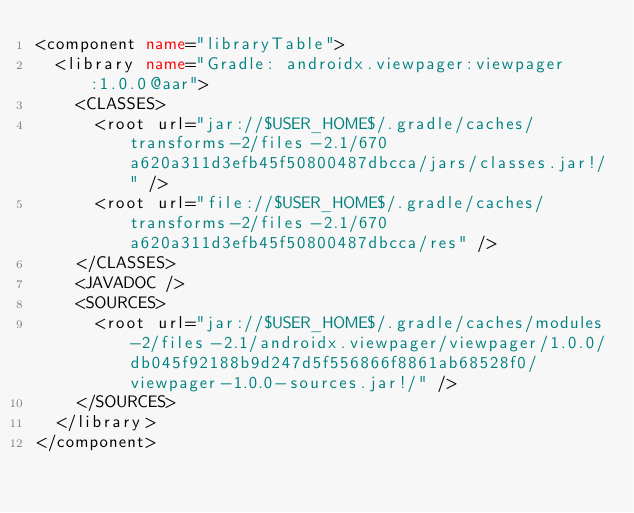Convert code to text. <code><loc_0><loc_0><loc_500><loc_500><_XML_><component name="libraryTable">
  <library name="Gradle: androidx.viewpager:viewpager:1.0.0@aar">
    <CLASSES>
      <root url="jar://$USER_HOME$/.gradle/caches/transforms-2/files-2.1/670a620a311d3efb45f50800487dbcca/jars/classes.jar!/" />
      <root url="file://$USER_HOME$/.gradle/caches/transforms-2/files-2.1/670a620a311d3efb45f50800487dbcca/res" />
    </CLASSES>
    <JAVADOC />
    <SOURCES>
      <root url="jar://$USER_HOME$/.gradle/caches/modules-2/files-2.1/androidx.viewpager/viewpager/1.0.0/db045f92188b9d247d5f556866f8861ab68528f0/viewpager-1.0.0-sources.jar!/" />
    </SOURCES>
  </library>
</component></code> 